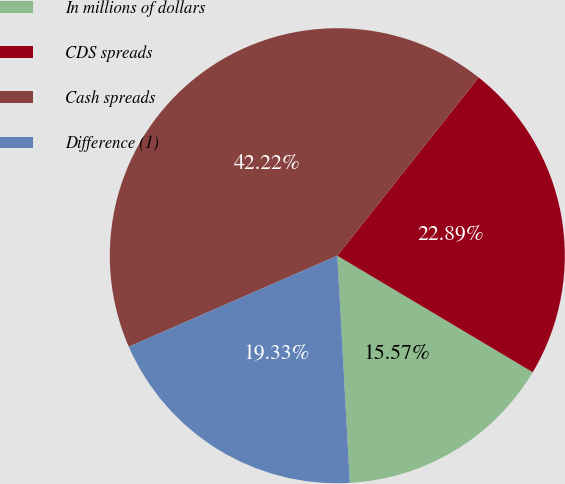Convert chart to OTSL. <chart><loc_0><loc_0><loc_500><loc_500><pie_chart><fcel>In millions of dollars<fcel>CDS spreads<fcel>Cash spreads<fcel>Difference (1)<nl><fcel>15.57%<fcel>22.89%<fcel>42.22%<fcel>19.33%<nl></chart> 